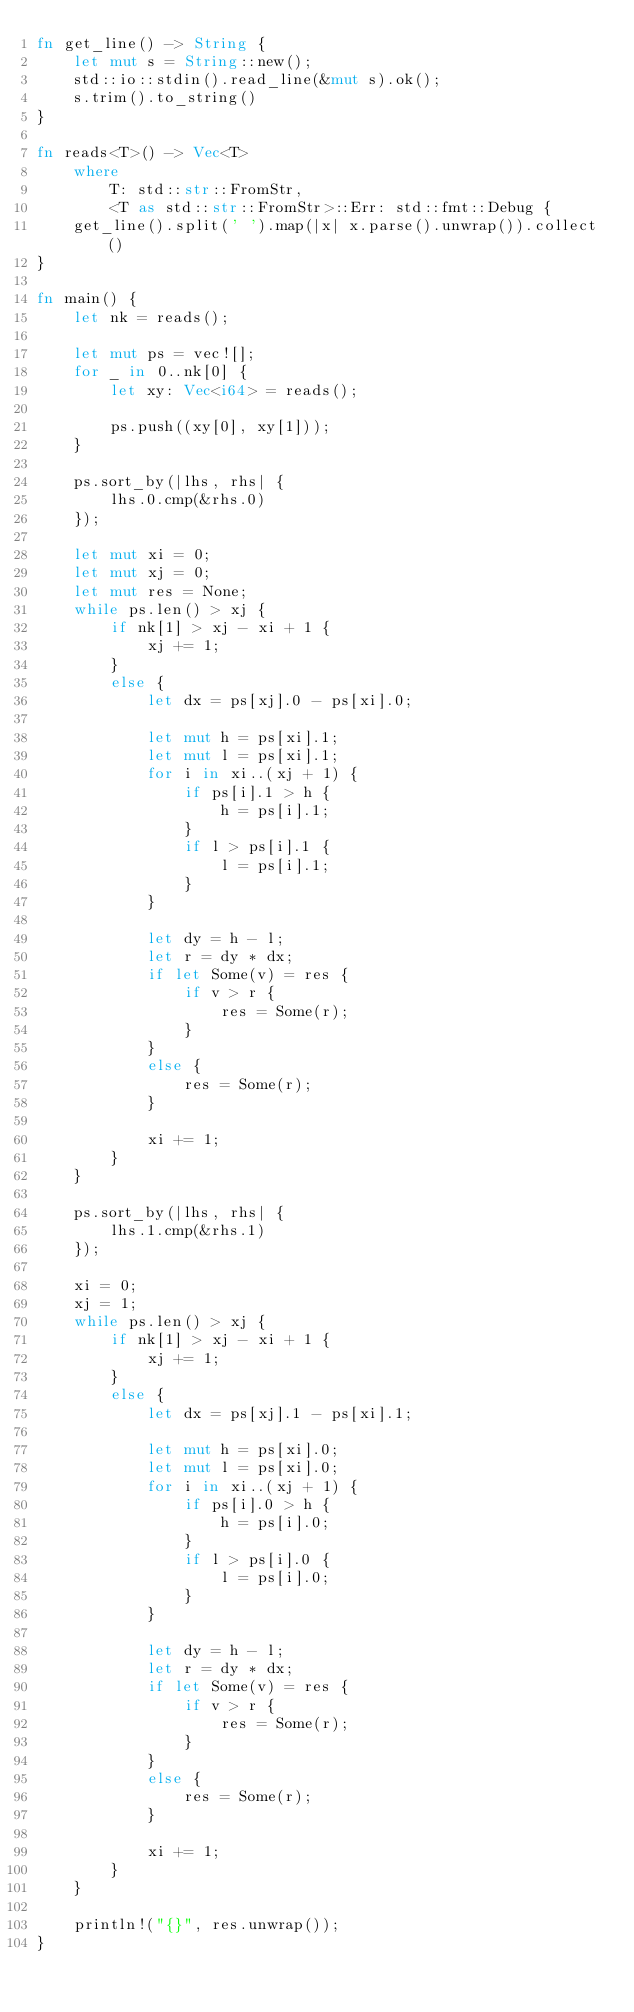Convert code to text. <code><loc_0><loc_0><loc_500><loc_500><_Rust_>fn get_line() -> String {
    let mut s = String::new();
    std::io::stdin().read_line(&mut s).ok();
    s.trim().to_string()
}

fn reads<T>() -> Vec<T>
    where
        T: std::str::FromStr,
        <T as std::str::FromStr>::Err: std::fmt::Debug {
    get_line().split(' ').map(|x| x.parse().unwrap()).collect()
}

fn main() {
    let nk = reads();

    let mut ps = vec![];
    for _ in 0..nk[0] {
        let xy: Vec<i64> = reads();

        ps.push((xy[0], xy[1]));
    }

    ps.sort_by(|lhs, rhs| {
        lhs.0.cmp(&rhs.0)
    });

    let mut xi = 0;
    let mut xj = 0;
    let mut res = None;
    while ps.len() > xj {
        if nk[1] > xj - xi + 1 {
            xj += 1;
        }
        else {
            let dx = ps[xj].0 - ps[xi].0;

            let mut h = ps[xi].1;
            let mut l = ps[xi].1;
            for i in xi..(xj + 1) {
                if ps[i].1 > h {
                    h = ps[i].1;
                }
                if l > ps[i].1 {
                    l = ps[i].1;
                }
            }

            let dy = h - l;
            let r = dy * dx;
            if let Some(v) = res {
                if v > r {
                    res = Some(r);
                }
            }
            else {
                res = Some(r);
            }

            xi += 1;
        }
    }

    ps.sort_by(|lhs, rhs| {
        lhs.1.cmp(&rhs.1)
    });

    xi = 0;
    xj = 1;
    while ps.len() > xj {
        if nk[1] > xj - xi + 1 {
            xj += 1;
        }
        else {
            let dx = ps[xj].1 - ps[xi].1;

            let mut h = ps[xi].0;
            let mut l = ps[xi].0;
            for i in xi..(xj + 1) {
                if ps[i].0 > h {
                    h = ps[i].0;
                }
                if l > ps[i].0 {
                    l = ps[i].0;
                }
            }

            let dy = h - l;
            let r = dy * dx;
            if let Some(v) = res {
                if v > r {
                    res = Some(r);
                }
            }
            else {
                res = Some(r);
            }

            xi += 1;
        }
    }

    println!("{}", res.unwrap());
}
</code> 